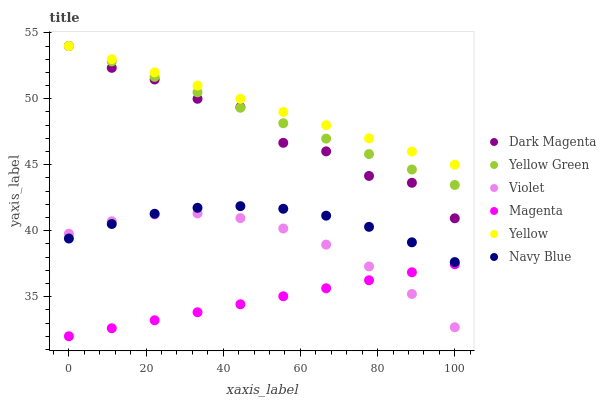Does Magenta have the minimum area under the curve?
Answer yes or no. Yes. Does Yellow have the maximum area under the curve?
Answer yes or no. Yes. Does Navy Blue have the minimum area under the curve?
Answer yes or no. No. Does Navy Blue have the maximum area under the curve?
Answer yes or no. No. Is Yellow Green the smoothest?
Answer yes or no. Yes. Is Dark Magenta the roughest?
Answer yes or no. Yes. Is Navy Blue the smoothest?
Answer yes or no. No. Is Navy Blue the roughest?
Answer yes or no. No. Does Magenta have the lowest value?
Answer yes or no. Yes. Does Navy Blue have the lowest value?
Answer yes or no. No. Does Yellow Green have the highest value?
Answer yes or no. Yes. Does Navy Blue have the highest value?
Answer yes or no. No. Is Violet less than Dark Magenta?
Answer yes or no. Yes. Is Dark Magenta greater than Violet?
Answer yes or no. Yes. Does Violet intersect Magenta?
Answer yes or no. Yes. Is Violet less than Magenta?
Answer yes or no. No. Is Violet greater than Magenta?
Answer yes or no. No. Does Violet intersect Dark Magenta?
Answer yes or no. No. 